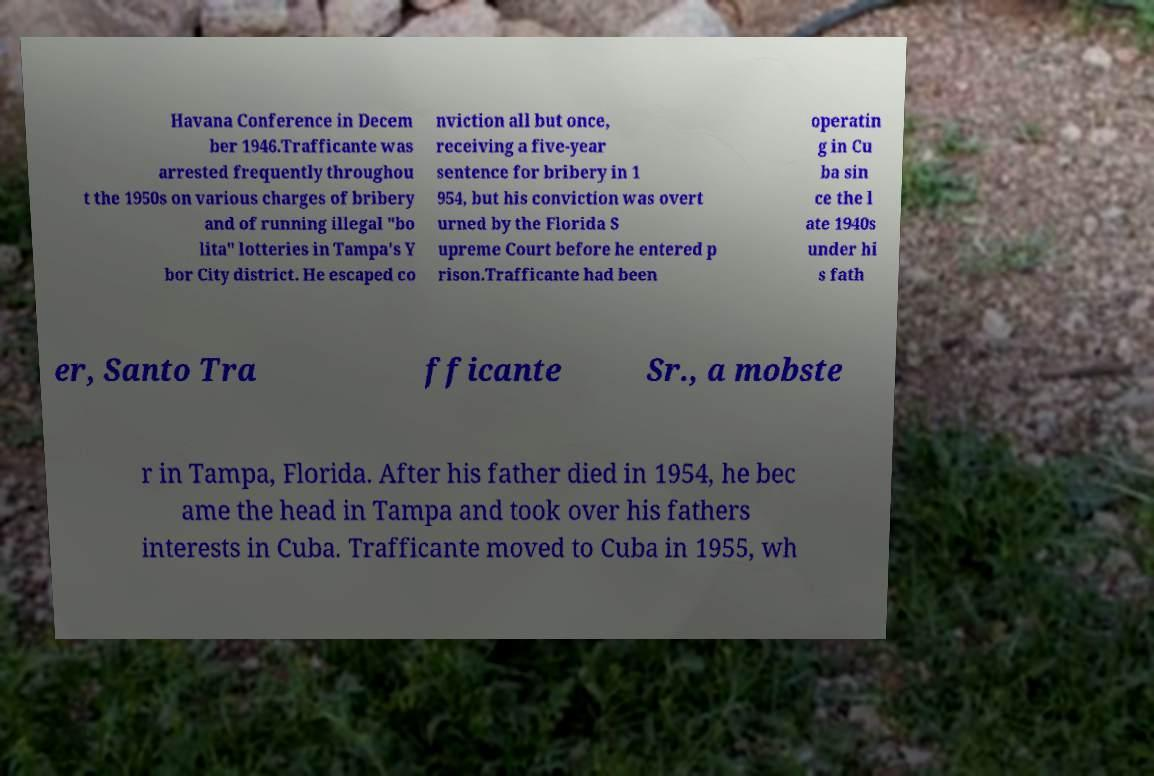Please read and relay the text visible in this image. What does it say? Havana Conference in Decem ber 1946.Trafficante was arrested frequently throughou t the 1950s on various charges of bribery and of running illegal "bo lita" lotteries in Tampa's Y bor City district. He escaped co nviction all but once, receiving a five-year sentence for bribery in 1 954, but his conviction was overt urned by the Florida S upreme Court before he entered p rison.Trafficante had been operatin g in Cu ba sin ce the l ate 1940s under hi s fath er, Santo Tra fficante Sr., a mobste r in Tampa, Florida. After his father died in 1954, he bec ame the head in Tampa and took over his fathers interests in Cuba. Trafficante moved to Cuba in 1955, wh 